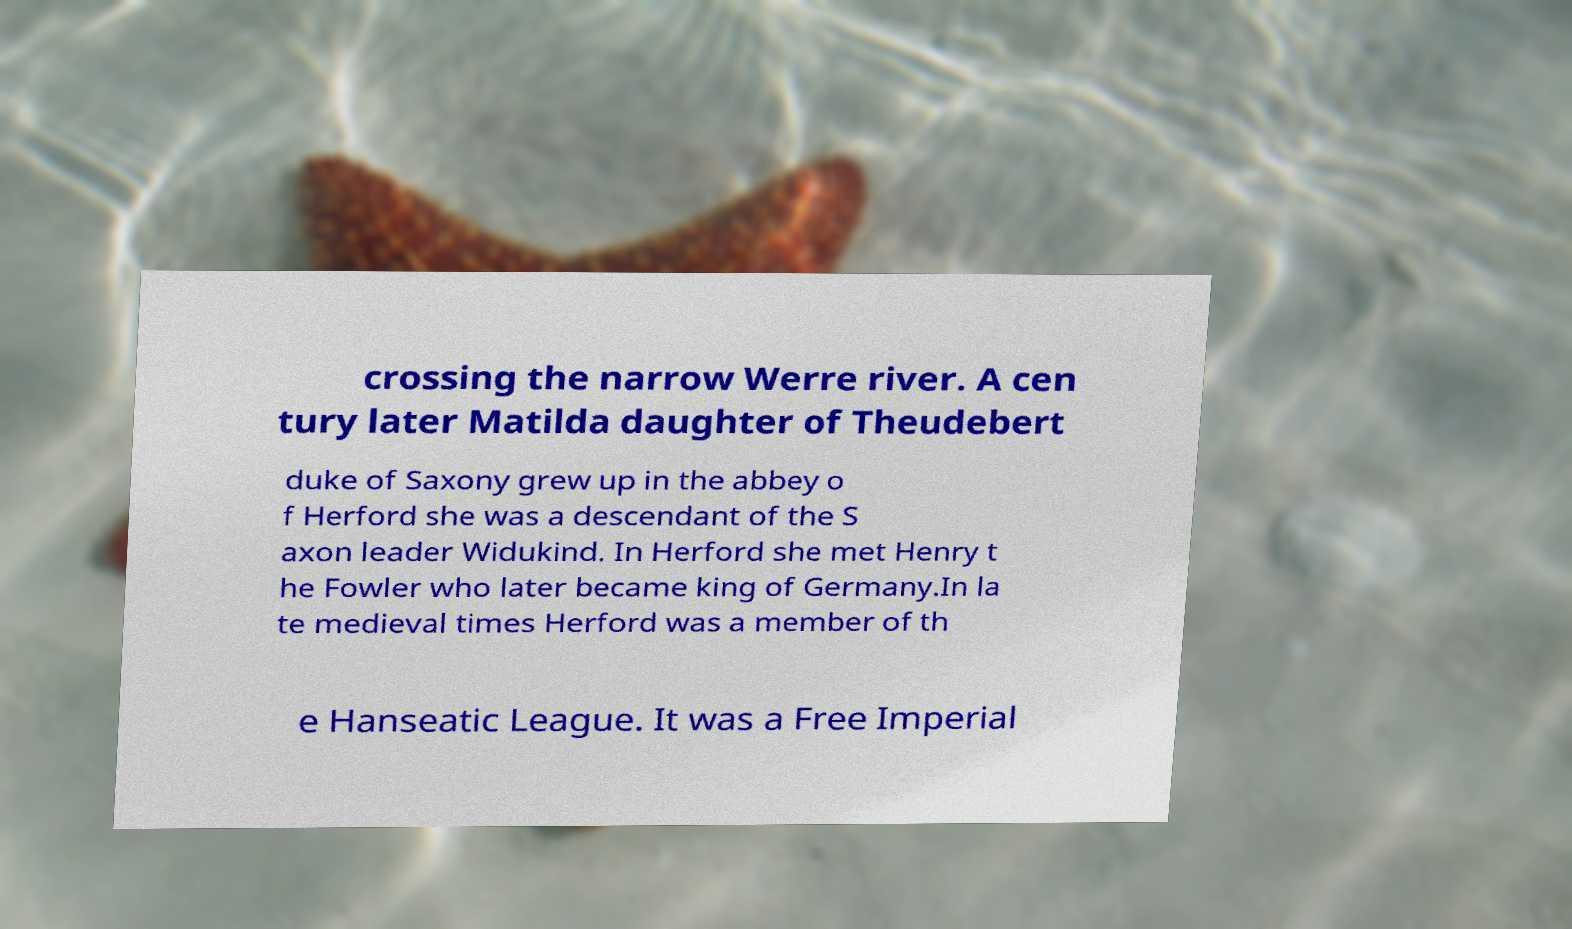For documentation purposes, I need the text within this image transcribed. Could you provide that? crossing the narrow Werre river. A cen tury later Matilda daughter of Theudebert duke of Saxony grew up in the abbey o f Herford she was a descendant of the S axon leader Widukind. In Herford she met Henry t he Fowler who later became king of Germany.In la te medieval times Herford was a member of th e Hanseatic League. It was a Free Imperial 